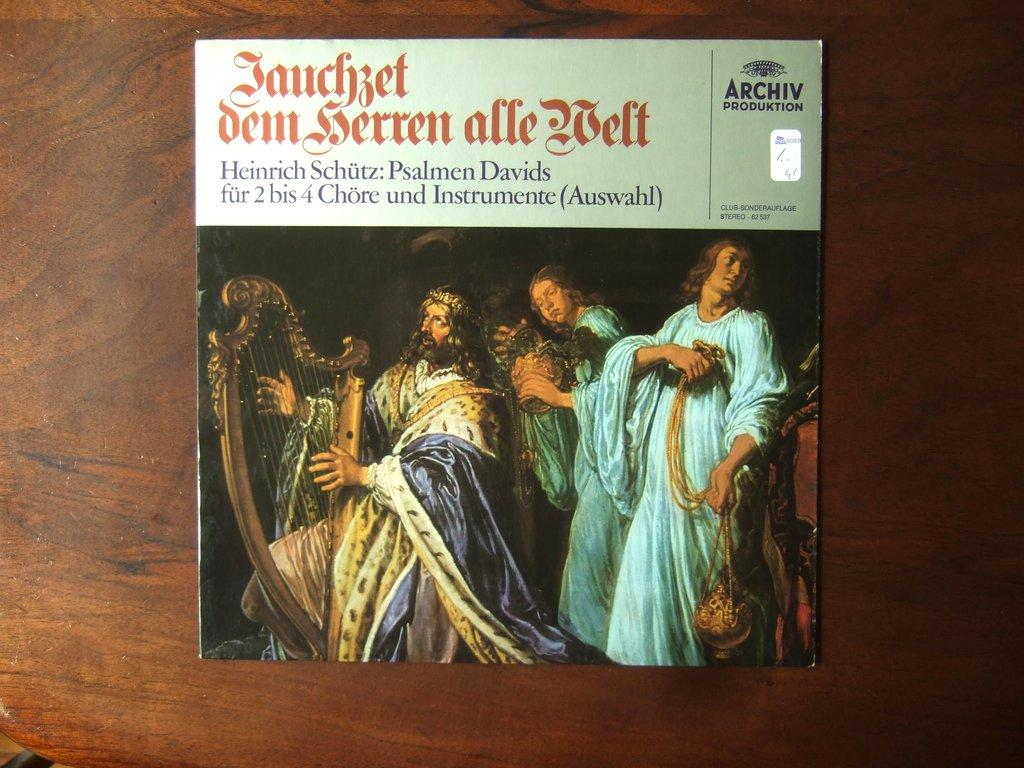<image>
Relay a brief, clear account of the picture shown. Old time Victorian band including a harp and drum plus incense 